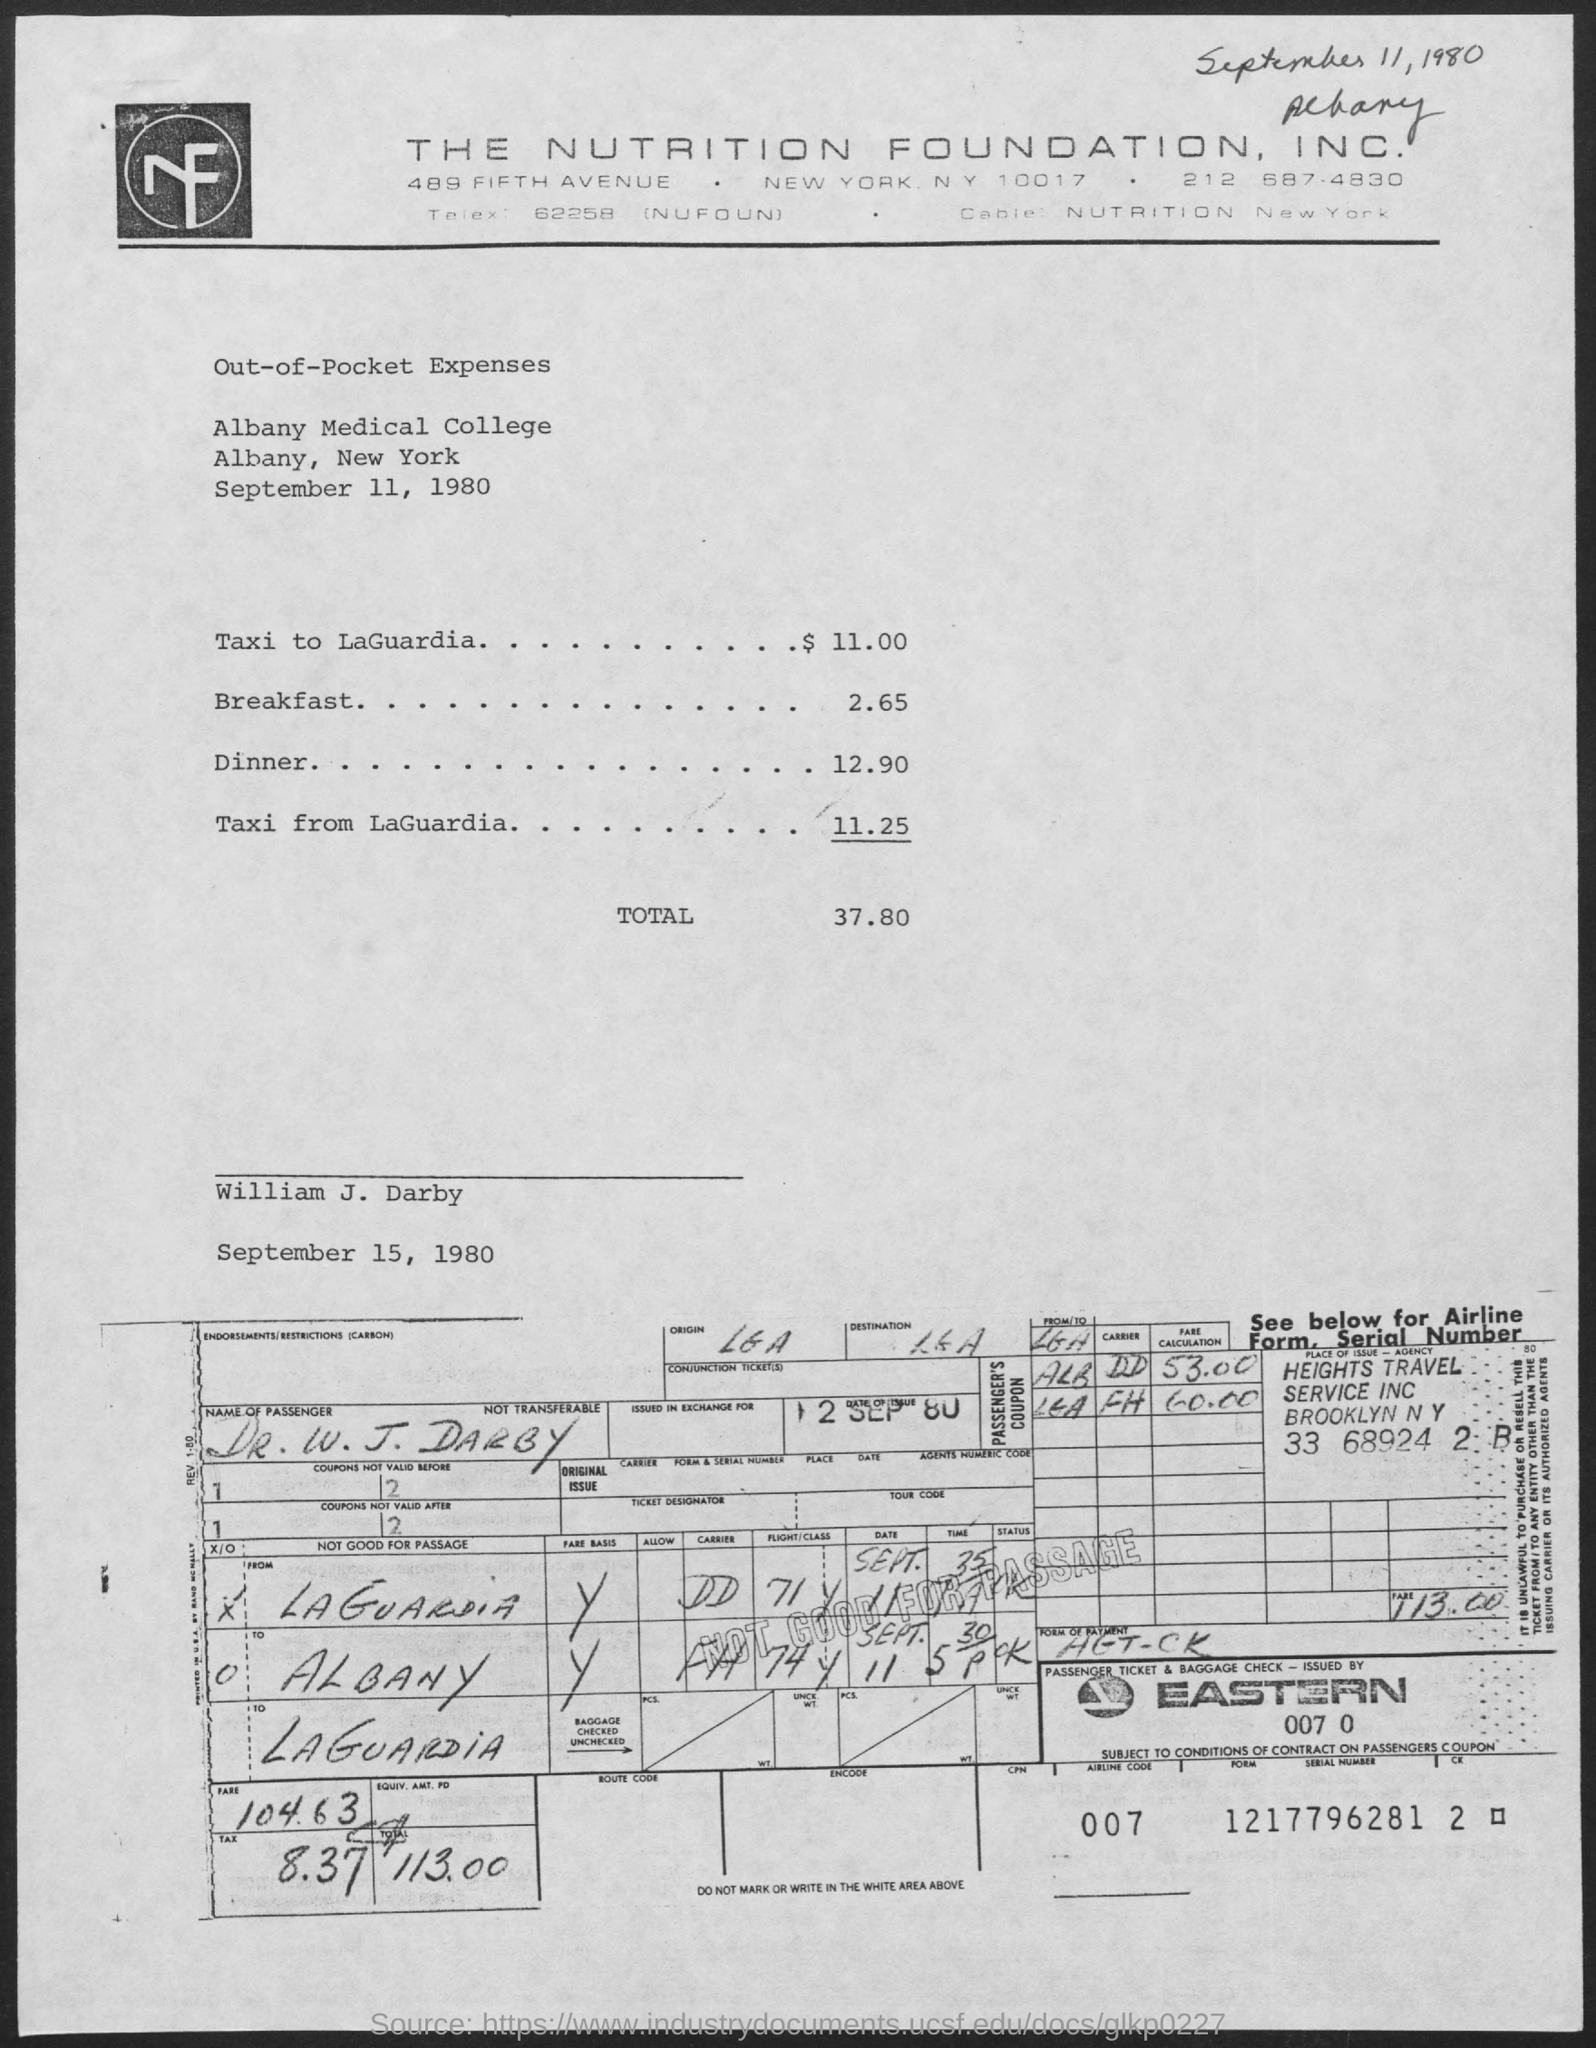Draw attention to some important aspects in this diagram. The total amount of out-of-pocket expenses is 37.80. The date mentioned on the top is September 11, 1980. The expenses listed are out-of-pocket expenses. The cost of dinner is 12.90. The passenger's name is Dr. W. J. Darby. 